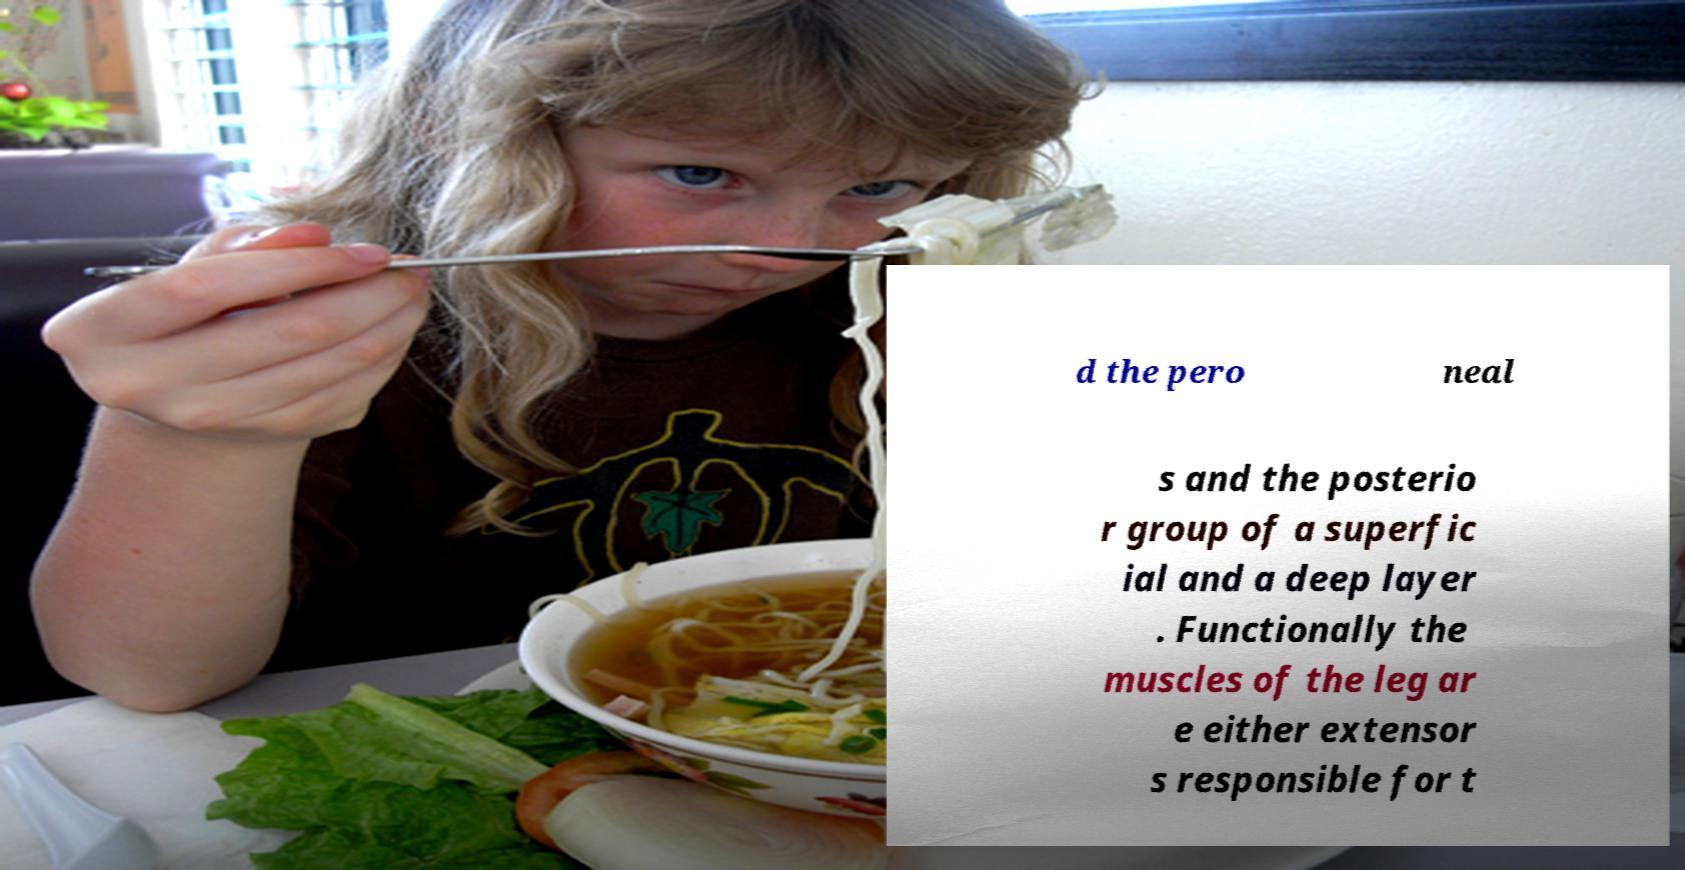Can you read and provide the text displayed in the image?This photo seems to have some interesting text. Can you extract and type it out for me? d the pero neal s and the posterio r group of a superfic ial and a deep layer . Functionally the muscles of the leg ar e either extensor s responsible for t 